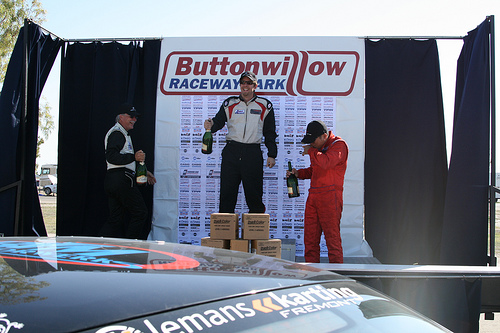<image>
Is the man behind the box? Yes. From this viewpoint, the man is positioned behind the box, with the box partially or fully occluding the man. 